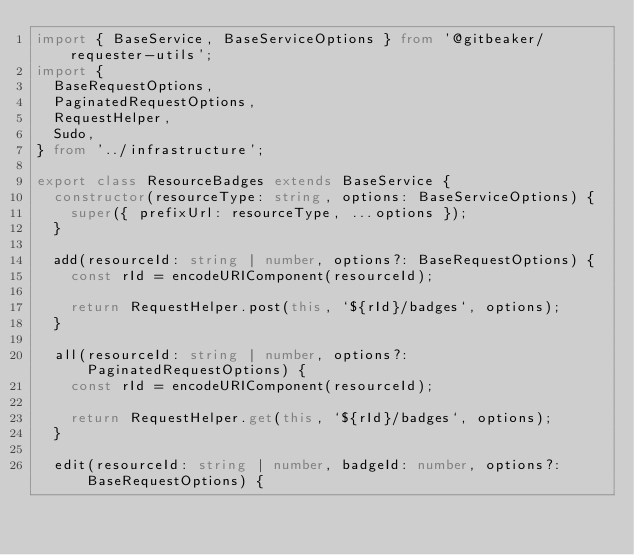<code> <loc_0><loc_0><loc_500><loc_500><_TypeScript_>import { BaseService, BaseServiceOptions } from '@gitbeaker/requester-utils';
import {
  BaseRequestOptions,
  PaginatedRequestOptions,
  RequestHelper,
  Sudo,
} from '../infrastructure';

export class ResourceBadges extends BaseService {
  constructor(resourceType: string, options: BaseServiceOptions) {
    super({ prefixUrl: resourceType, ...options });
  }

  add(resourceId: string | number, options?: BaseRequestOptions) {
    const rId = encodeURIComponent(resourceId);

    return RequestHelper.post(this, `${rId}/badges`, options);
  }

  all(resourceId: string | number, options?: PaginatedRequestOptions) {
    const rId = encodeURIComponent(resourceId);

    return RequestHelper.get(this, `${rId}/badges`, options);
  }

  edit(resourceId: string | number, badgeId: number, options?: BaseRequestOptions) {</code> 